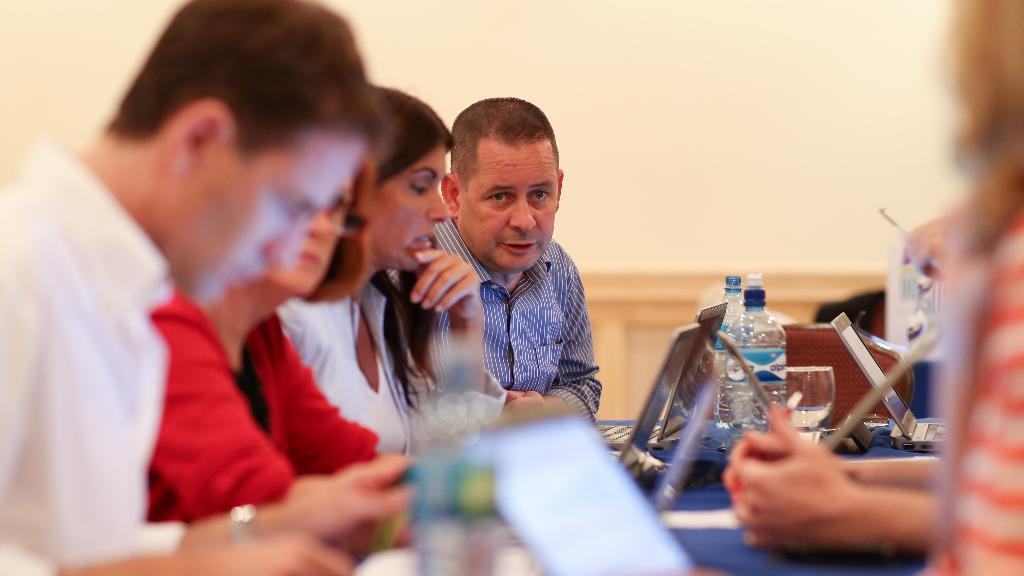Could you give a brief overview of what you see in this image? On the left side of the image we can see persons sitting on the chairs and engaging with themselves. On the right side of the image we can see laptops, glass tumbler, plastic water bottle and a person. 